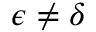Convert formula to latex. <formula><loc_0><loc_0><loc_500><loc_500>\epsilon \neq \delta</formula> 